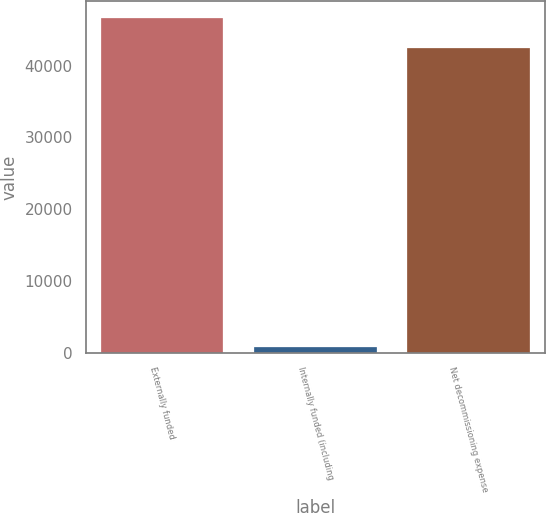Convert chart. <chart><loc_0><loc_0><loc_500><loc_500><bar_chart><fcel>Externally funded<fcel>Internally funded (including<fcel>Net decommissioning expense<nl><fcel>46662<fcel>819<fcel>42420<nl></chart> 